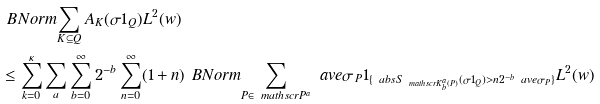Convert formula to latex. <formula><loc_0><loc_0><loc_500><loc_500>& \ B N o r m { \sum _ { K \subseteq Q } A _ { K } ( \sigma 1 _ { Q } ) } { L ^ { 2 } ( w ) } \\ & \leq \sum _ { k = 0 } ^ { \kappa } \sum _ { a } \sum _ { b = 0 } ^ { \infty } 2 ^ { - b } \sum _ { n = 0 } ^ { \infty } ( 1 + n ) \ B N o r m { \sum _ { P \in \ m a t h s c r { P } ^ { a } } \ a v e { \sigma } _ { P } 1 _ { \{ \ a b s { S _ { \ m a t h s c r { K } ^ { a } _ { b } ( P ) } ( \sigma 1 _ { Q } ) } > n 2 ^ { - b } \ a v e { \sigma } _ { P } \} } } { L ^ { 2 } ( w ) }</formula> 